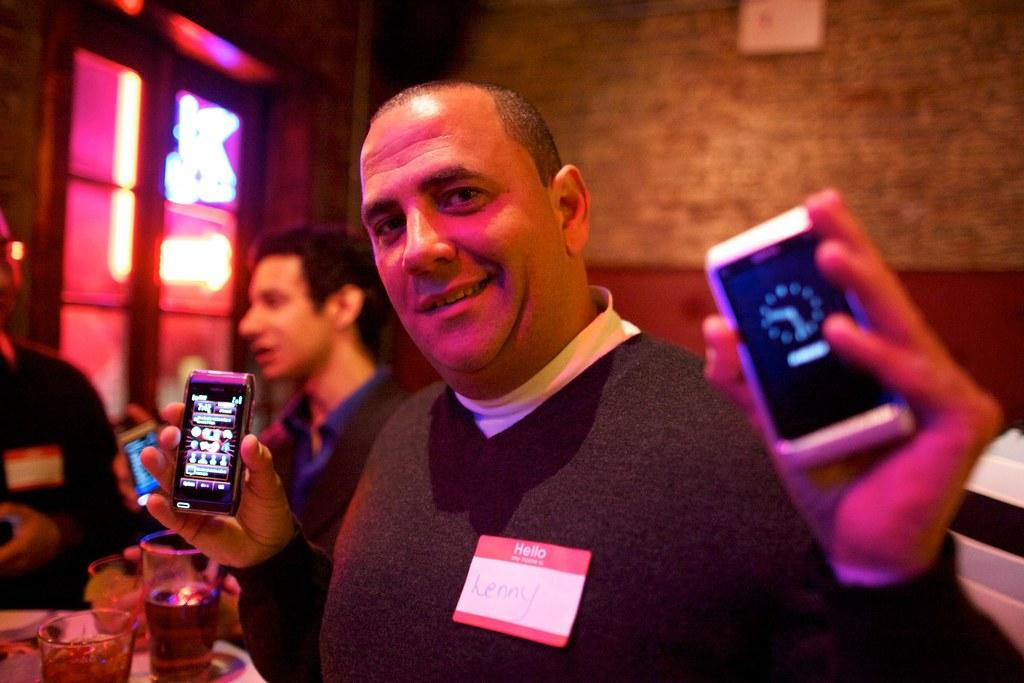<image>
Give a short and clear explanation of the subsequent image. man named lenny holding a phone in each hand 